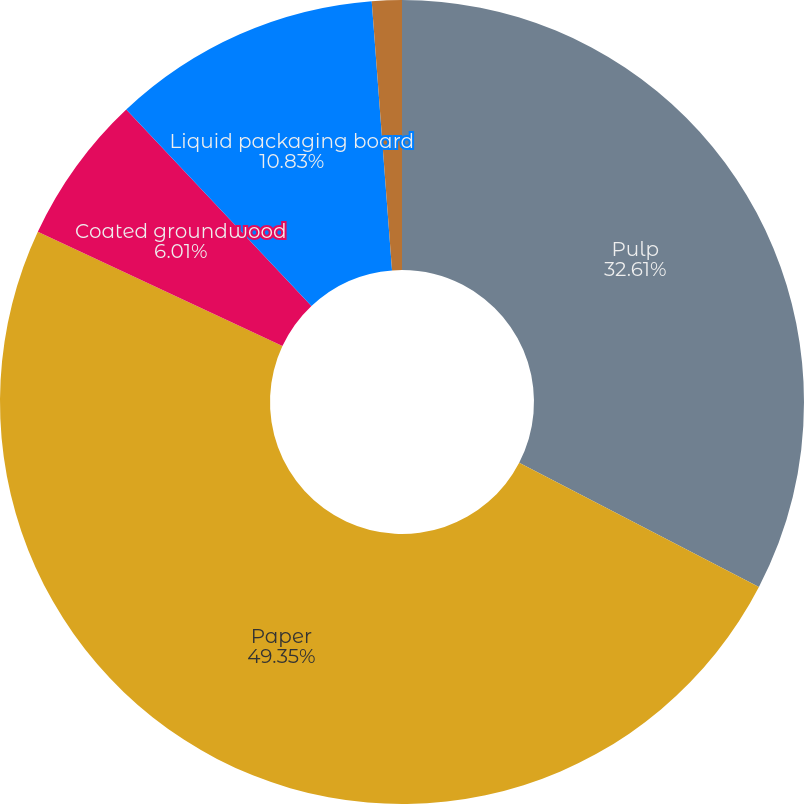Convert chart. <chart><loc_0><loc_0><loc_500><loc_500><pie_chart><fcel>Pulp<fcel>Paper<fcel>Coated groundwood<fcel>Liquid packaging board<fcel>Other products<nl><fcel>32.61%<fcel>49.35%<fcel>6.01%<fcel>10.83%<fcel>1.2%<nl></chart> 